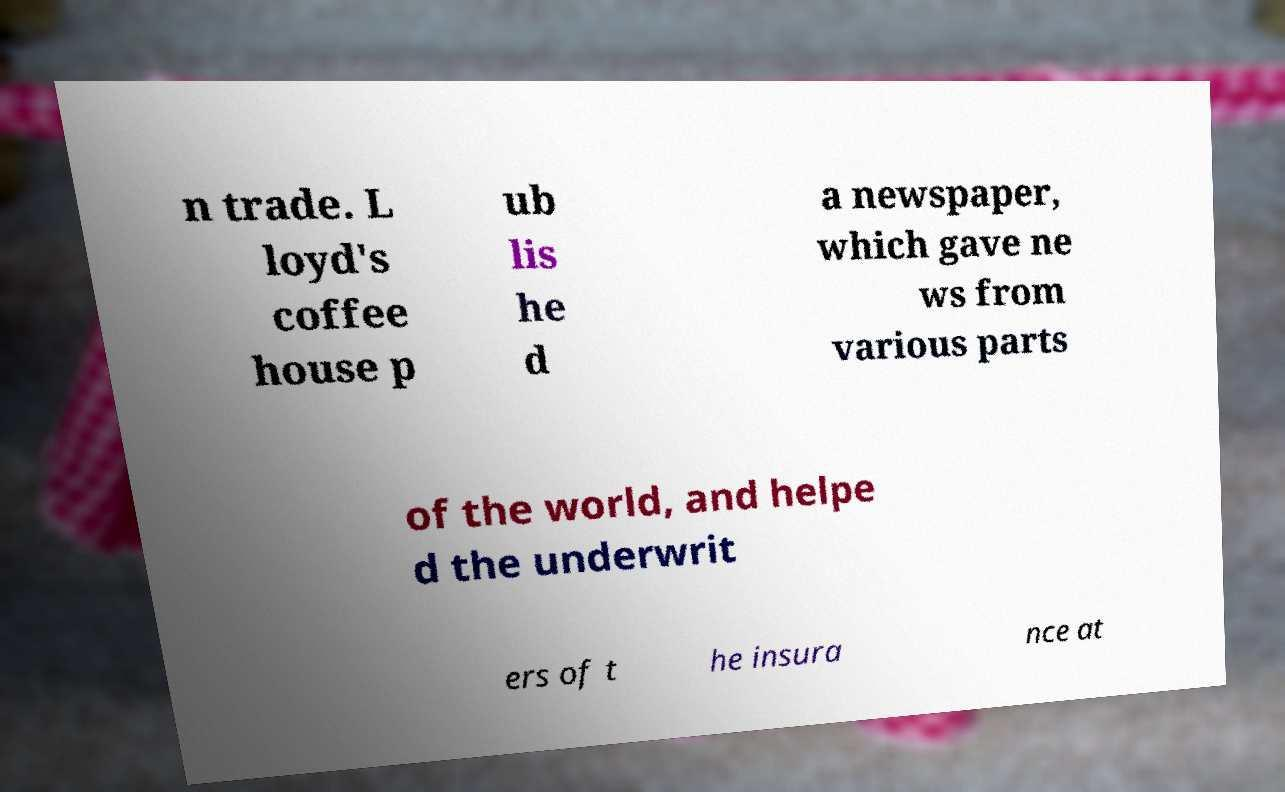For documentation purposes, I need the text within this image transcribed. Could you provide that? n trade. L loyd's coffee house p ub lis he d a newspaper, which gave ne ws from various parts of the world, and helpe d the underwrit ers of t he insura nce at 